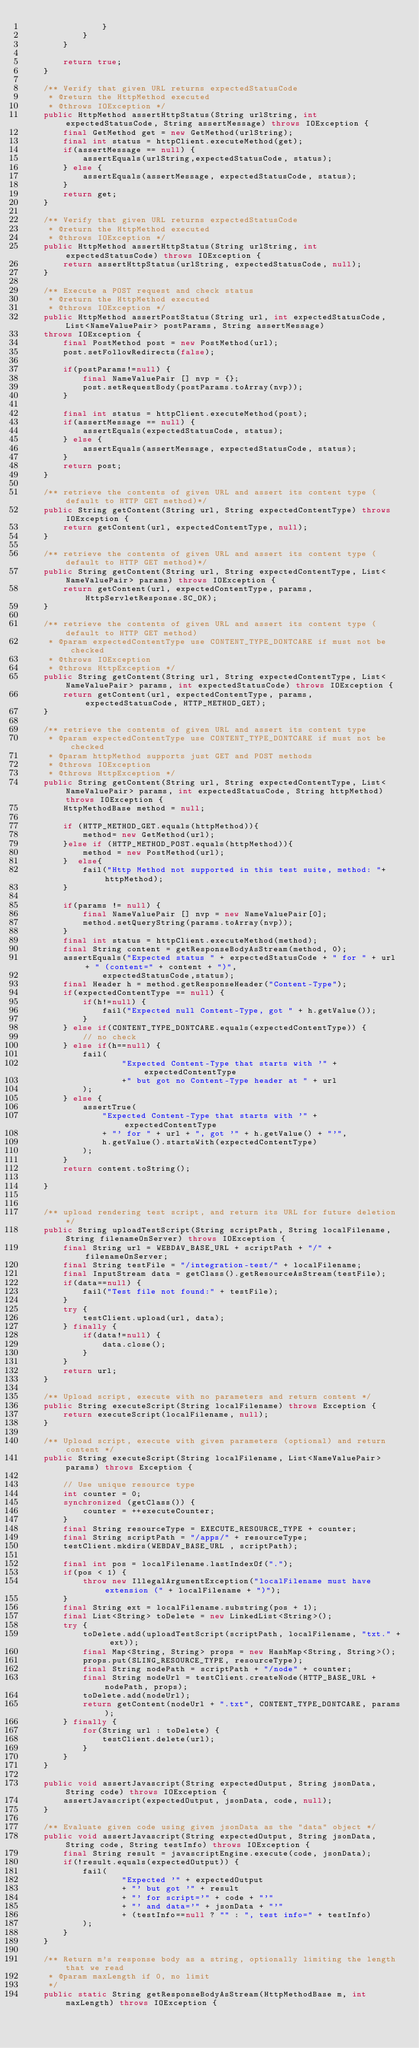Convert code to text. <code><loc_0><loc_0><loc_500><loc_500><_Java_>                }
            }
        }

        return true;
    }

    /** Verify that given URL returns expectedStatusCode
     * @return the HttpMethod executed
     * @throws IOException */
    public HttpMethod assertHttpStatus(String urlString, int expectedStatusCode, String assertMessage) throws IOException {
        final GetMethod get = new GetMethod(urlString);
        final int status = httpClient.executeMethod(get);
        if(assertMessage == null) {
            assertEquals(urlString,expectedStatusCode, status);
        } else {
            assertEquals(assertMessage, expectedStatusCode, status);
        }
        return get;
    }

    /** Verify that given URL returns expectedStatusCode
     * @return the HttpMethod executed
     * @throws IOException */
    public HttpMethod assertHttpStatus(String urlString, int expectedStatusCode) throws IOException {
        return assertHttpStatus(urlString, expectedStatusCode, null);
    }

    /** Execute a POST request and check status
     * @return the HttpMethod executed
     * @throws IOException */
    public HttpMethod assertPostStatus(String url, int expectedStatusCode, List<NameValuePair> postParams, String assertMessage)
    throws IOException {
        final PostMethod post = new PostMethod(url);
        post.setFollowRedirects(false);

        if(postParams!=null) {
            final NameValuePair [] nvp = {};
            post.setRequestBody(postParams.toArray(nvp));
        }

        final int status = httpClient.executeMethod(post);
        if(assertMessage == null) {
            assertEquals(expectedStatusCode, status);
        } else {
            assertEquals(assertMessage, expectedStatusCode, status);
        }
        return post;
    }

    /** retrieve the contents of given URL and assert its content type (default to HTTP GET method)*/
    public String getContent(String url, String expectedContentType) throws IOException {
        return getContent(url, expectedContentType, null);
    }

    /** retrieve the contents of given URL and assert its content type (default to HTTP GET method)*/
    public String getContent(String url, String expectedContentType, List<NameValuePair> params) throws IOException {
        return getContent(url, expectedContentType, params, HttpServletResponse.SC_OK);
    }

    /** retrieve the contents of given URL and assert its content type (default to HTTP GET method)
     * @param expectedContentType use CONTENT_TYPE_DONTCARE if must not be checked
     * @throws IOException
     * @throws HttpException */
    public String getContent(String url, String expectedContentType, List<NameValuePair> params, int expectedStatusCode) throws IOException {
    	return getContent(url, expectedContentType, params, expectedStatusCode, HTTP_METHOD_GET);
    }
    
    /** retrieve the contents of given URL and assert its content type
     * @param expectedContentType use CONTENT_TYPE_DONTCARE if must not be checked
     * @param httpMethod supports just GET and POST methods
     * @throws IOException
     * @throws HttpException */
    public String getContent(String url, String expectedContentType, List<NameValuePair> params, int expectedStatusCode, String httpMethod) throws IOException {
    	HttpMethodBase method = null;
    	
    	if (HTTP_METHOD_GET.equals(httpMethod)){
    		method= new GetMethod(url);
    	}else if (HTTP_METHOD_POST.equals(httpMethod)){
    		method = new PostMethod(url);
    	}  else{
    		fail("Http Method not supported in this test suite, method: "+httpMethod);
    	}
    	
    	if(params != null) {
            final NameValuePair [] nvp = new NameValuePair[0];
            method.setQueryString(params.toArray(nvp));
        }
        final int status = httpClient.executeMethod(method);
        final String content = getResponseBodyAsStream(method, 0);
        assertEquals("Expected status " + expectedStatusCode + " for " + url + " (content=" + content + ")",
                expectedStatusCode,status);
        final Header h = method.getResponseHeader("Content-Type");
        if(expectedContentType == null) {
            if(h!=null) {
                fail("Expected null Content-Type, got " + h.getValue());
            }
        } else if(CONTENT_TYPE_DONTCARE.equals(expectedContentType)) {
            // no check
        } else if(h==null) {
            fail(
                    "Expected Content-Type that starts with '" + expectedContentType
                    +" but got no Content-Type header at " + url
            );
        } else {
            assertTrue(
                "Expected Content-Type that starts with '" + expectedContentType
                + "' for " + url + ", got '" + h.getValue() + "'",
                h.getValue().startsWith(expectedContentType)
            );
        }
        return content.toString();
    	
    }
    

    /** upload rendering test script, and return its URL for future deletion */
    public String uploadTestScript(String scriptPath, String localFilename,String filenameOnServer) throws IOException {
        final String url = WEBDAV_BASE_URL + scriptPath + "/" + filenameOnServer;
        final String testFile = "/integration-test/" + localFilename;
        final InputStream data = getClass().getResourceAsStream(testFile);
        if(data==null) {
            fail("Test file not found:" + testFile);
        }
        try {
            testClient.upload(url, data);
        } finally {
            if(data!=null) {
                data.close();
            }
        }
        return url;
    }

    /** Upload script, execute with no parameters and return content */
    public String executeScript(String localFilename) throws Exception {
        return executeScript(localFilename, null);
    }

    /** Upload script, execute with given parameters (optional) and return content */
    public String executeScript(String localFilename, List<NameValuePair> params) throws Exception {

        // Use unique resource type
        int counter = 0;
        synchronized (getClass()) {
            counter = ++executeCounter;
        }
        final String resourceType = EXECUTE_RESOURCE_TYPE + counter;
        final String scriptPath = "/apps/" + resourceType;
        testClient.mkdirs(WEBDAV_BASE_URL , scriptPath);

        final int pos = localFilename.lastIndexOf(".");
        if(pos < 1) {
            throw new IllegalArgumentException("localFilename must have extension (" + localFilename + ")");
        }
        final String ext = localFilename.substring(pos + 1);
        final List<String> toDelete = new LinkedList<String>();
        try {
            toDelete.add(uploadTestScript(scriptPath, localFilename, "txt." + ext));
            final Map<String, String> props = new HashMap<String, String>();
            props.put(SLING_RESOURCE_TYPE, resourceType);
            final String nodePath = scriptPath + "/node" + counter;
            final String nodeUrl = testClient.createNode(HTTP_BASE_URL + nodePath, props);
            toDelete.add(nodeUrl);
            return getContent(nodeUrl + ".txt", CONTENT_TYPE_DONTCARE, params);
        } finally {
            for(String url : toDelete) {
                testClient.delete(url);
            }
        }
    }

    public void assertJavascript(String expectedOutput, String jsonData, String code) throws IOException {
        assertJavascript(expectedOutput, jsonData, code, null);
    }

    /** Evaluate given code using given jsonData as the "data" object */
    public void assertJavascript(String expectedOutput, String jsonData, String code, String testInfo) throws IOException {
    	final String result = javascriptEngine.execute(code, jsonData);
        if(!result.equals(expectedOutput)) {
            fail(
                    "Expected '" + expectedOutput
                    + "' but got '" + result
                    + "' for script='" + code + "'"
                    + "' and data='" + jsonData + "'"
                    + (testInfo==null ? "" : ", test info=" + testInfo)
            );
        }
    }

    /** Return m's response body as a string, optionally limiting the length that we read
     * @param maxLength if 0, no limit
     */
    public static String getResponseBodyAsStream(HttpMethodBase m, int maxLength) throws IOException {</code> 